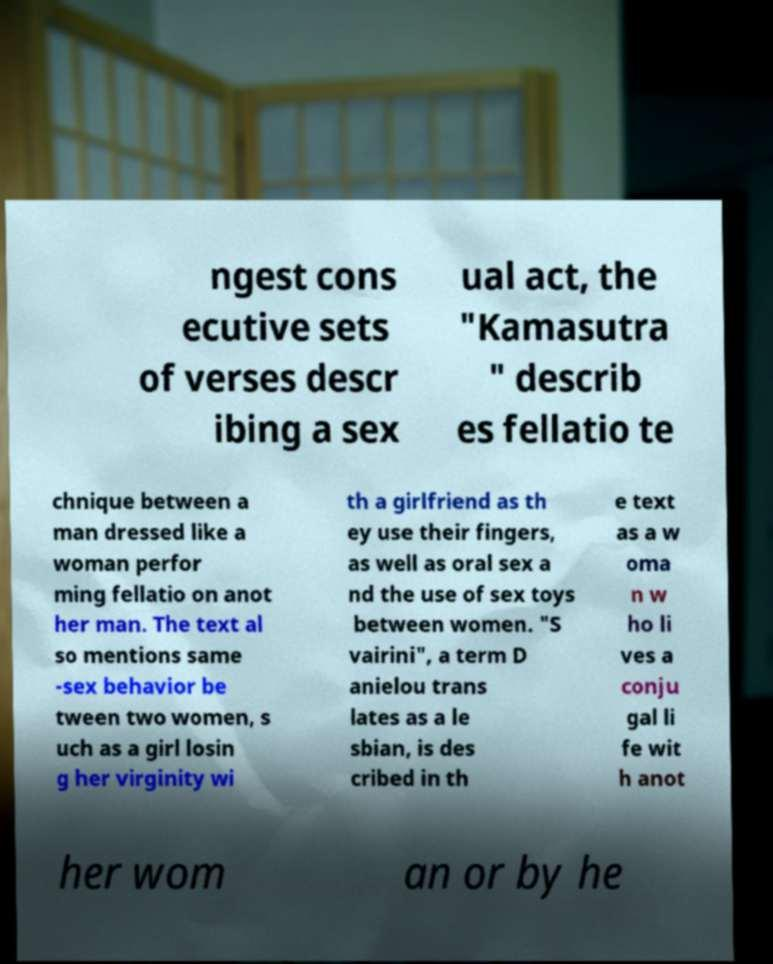Can you accurately transcribe the text from the provided image for me? ngest cons ecutive sets of verses descr ibing a sex ual act, the "Kamasutra " describ es fellatio te chnique between a man dressed like a woman perfor ming fellatio on anot her man. The text al so mentions same -sex behavior be tween two women, s uch as a girl losin g her virginity wi th a girlfriend as th ey use their fingers, as well as oral sex a nd the use of sex toys between women. "S vairini", a term D anielou trans lates as a le sbian, is des cribed in th e text as a w oma n w ho li ves a conju gal li fe wit h anot her wom an or by he 